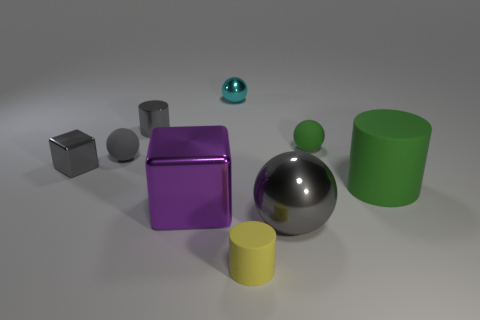Subtract all small cylinders. How many cylinders are left? 1 Subtract all blocks. How many objects are left? 7 Subtract 3 cylinders. How many cylinders are left? 0 Subtract all green balls. Subtract all red cylinders. How many balls are left? 3 Subtract all purple cylinders. How many green spheres are left? 1 Subtract all yellow matte objects. Subtract all big gray metallic objects. How many objects are left? 7 Add 1 big purple cubes. How many big purple cubes are left? 2 Add 7 tiny yellow rubber things. How many tiny yellow rubber things exist? 8 Subtract all cyan balls. How many balls are left? 3 Subtract 0 blue balls. How many objects are left? 9 